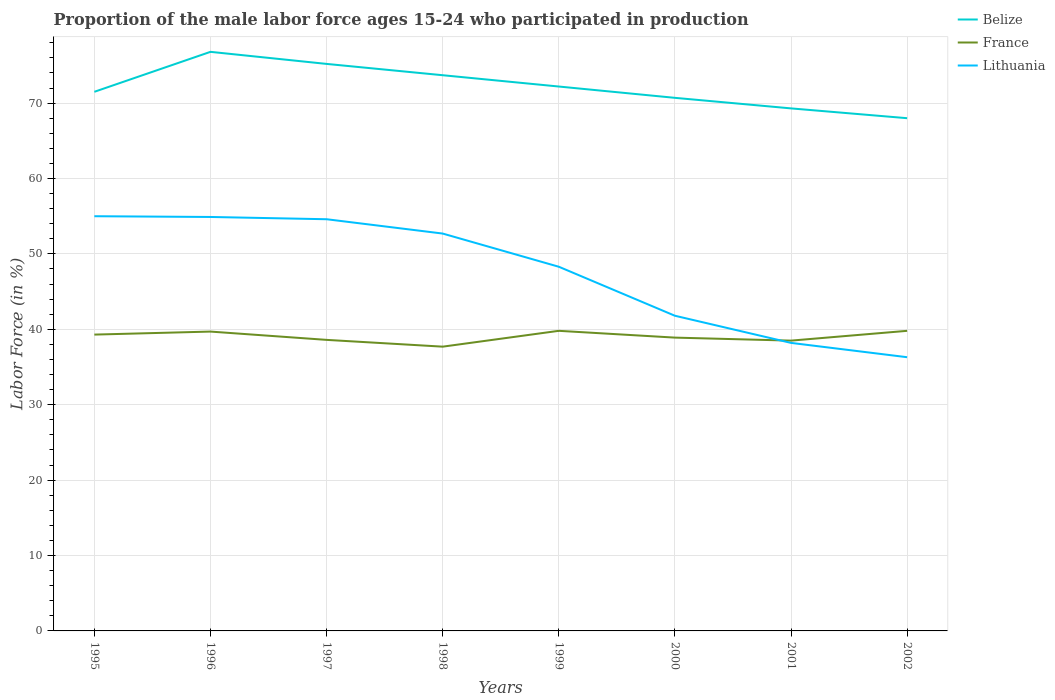Does the line corresponding to France intersect with the line corresponding to Belize?
Provide a short and direct response. No. In which year was the proportion of the male labor force who participated in production in Lithuania maximum?
Provide a succinct answer. 2002. What is the total proportion of the male labor force who participated in production in France in the graph?
Your response must be concise. -2.1. What is the difference between the highest and the second highest proportion of the male labor force who participated in production in Lithuania?
Your answer should be compact. 18.7. What is the difference between the highest and the lowest proportion of the male labor force who participated in production in Lithuania?
Your answer should be very brief. 5. Is the proportion of the male labor force who participated in production in France strictly greater than the proportion of the male labor force who participated in production in Belize over the years?
Provide a short and direct response. Yes. How many legend labels are there?
Give a very brief answer. 3. What is the title of the graph?
Provide a succinct answer. Proportion of the male labor force ages 15-24 who participated in production. Does "Mauritania" appear as one of the legend labels in the graph?
Offer a terse response. No. What is the label or title of the X-axis?
Offer a terse response. Years. What is the label or title of the Y-axis?
Offer a terse response. Labor Force (in %). What is the Labor Force (in %) of Belize in 1995?
Provide a succinct answer. 71.5. What is the Labor Force (in %) in France in 1995?
Offer a terse response. 39.3. What is the Labor Force (in %) in Belize in 1996?
Provide a succinct answer. 76.8. What is the Labor Force (in %) of France in 1996?
Your answer should be compact. 39.7. What is the Labor Force (in %) in Lithuania in 1996?
Provide a succinct answer. 54.9. What is the Labor Force (in %) of Belize in 1997?
Your response must be concise. 75.2. What is the Labor Force (in %) of France in 1997?
Provide a succinct answer. 38.6. What is the Labor Force (in %) of Lithuania in 1997?
Your answer should be compact. 54.6. What is the Labor Force (in %) in Belize in 1998?
Offer a very short reply. 73.7. What is the Labor Force (in %) in France in 1998?
Keep it short and to the point. 37.7. What is the Labor Force (in %) in Lithuania in 1998?
Offer a terse response. 52.7. What is the Labor Force (in %) in Belize in 1999?
Offer a terse response. 72.2. What is the Labor Force (in %) in France in 1999?
Offer a very short reply. 39.8. What is the Labor Force (in %) of Lithuania in 1999?
Provide a succinct answer. 48.3. What is the Labor Force (in %) of Belize in 2000?
Make the answer very short. 70.7. What is the Labor Force (in %) in France in 2000?
Your response must be concise. 38.9. What is the Labor Force (in %) of Lithuania in 2000?
Your response must be concise. 41.8. What is the Labor Force (in %) in Belize in 2001?
Your answer should be compact. 69.3. What is the Labor Force (in %) in France in 2001?
Keep it short and to the point. 38.5. What is the Labor Force (in %) in Lithuania in 2001?
Make the answer very short. 38.2. What is the Labor Force (in %) in France in 2002?
Offer a terse response. 39.8. What is the Labor Force (in %) in Lithuania in 2002?
Offer a very short reply. 36.3. Across all years, what is the maximum Labor Force (in %) in Belize?
Give a very brief answer. 76.8. Across all years, what is the maximum Labor Force (in %) of France?
Give a very brief answer. 39.8. Across all years, what is the maximum Labor Force (in %) of Lithuania?
Your answer should be compact. 55. Across all years, what is the minimum Labor Force (in %) of France?
Offer a very short reply. 37.7. Across all years, what is the minimum Labor Force (in %) in Lithuania?
Provide a short and direct response. 36.3. What is the total Labor Force (in %) in Belize in the graph?
Your response must be concise. 577.4. What is the total Labor Force (in %) in France in the graph?
Your response must be concise. 312.3. What is the total Labor Force (in %) in Lithuania in the graph?
Your answer should be very brief. 381.8. What is the difference between the Labor Force (in %) of Lithuania in 1995 and that in 1996?
Provide a succinct answer. 0.1. What is the difference between the Labor Force (in %) of France in 1995 and that in 1997?
Offer a terse response. 0.7. What is the difference between the Labor Force (in %) in Belize in 1995 and that in 1998?
Your response must be concise. -2.2. What is the difference between the Labor Force (in %) of France in 1995 and that in 1998?
Your answer should be compact. 1.6. What is the difference between the Labor Force (in %) in Lithuania in 1995 and that in 1998?
Your response must be concise. 2.3. What is the difference between the Labor Force (in %) of France in 1995 and that in 2000?
Your answer should be compact. 0.4. What is the difference between the Labor Force (in %) in France in 1995 and that in 2001?
Your answer should be very brief. 0.8. What is the difference between the Labor Force (in %) in Lithuania in 1995 and that in 2001?
Provide a succinct answer. 16.8. What is the difference between the Labor Force (in %) of France in 1995 and that in 2002?
Make the answer very short. -0.5. What is the difference between the Labor Force (in %) of Belize in 1996 and that in 1997?
Offer a very short reply. 1.6. What is the difference between the Labor Force (in %) of Lithuania in 1996 and that in 1997?
Your response must be concise. 0.3. What is the difference between the Labor Force (in %) in France in 1996 and that in 1998?
Your answer should be compact. 2. What is the difference between the Labor Force (in %) of Lithuania in 1996 and that in 1998?
Provide a short and direct response. 2.2. What is the difference between the Labor Force (in %) of Lithuania in 1996 and that in 1999?
Keep it short and to the point. 6.6. What is the difference between the Labor Force (in %) in Belize in 1996 and that in 2000?
Ensure brevity in your answer.  6.1. What is the difference between the Labor Force (in %) in France in 1996 and that in 2000?
Offer a very short reply. 0.8. What is the difference between the Labor Force (in %) of Belize in 1996 and that in 2001?
Ensure brevity in your answer.  7.5. What is the difference between the Labor Force (in %) in France in 1996 and that in 2001?
Ensure brevity in your answer.  1.2. What is the difference between the Labor Force (in %) in Lithuania in 1996 and that in 2001?
Keep it short and to the point. 16.7. What is the difference between the Labor Force (in %) in Belize in 1996 and that in 2002?
Give a very brief answer. 8.8. What is the difference between the Labor Force (in %) in Lithuania in 1996 and that in 2002?
Make the answer very short. 18.6. What is the difference between the Labor Force (in %) in France in 1997 and that in 1998?
Your answer should be compact. 0.9. What is the difference between the Labor Force (in %) of Lithuania in 1997 and that in 1998?
Offer a terse response. 1.9. What is the difference between the Labor Force (in %) in France in 1997 and that in 1999?
Provide a succinct answer. -1.2. What is the difference between the Labor Force (in %) in France in 1997 and that in 2000?
Keep it short and to the point. -0.3. What is the difference between the Labor Force (in %) in Lithuania in 1997 and that in 2000?
Give a very brief answer. 12.8. What is the difference between the Labor Force (in %) of France in 1997 and that in 2001?
Your response must be concise. 0.1. What is the difference between the Labor Force (in %) in Lithuania in 1997 and that in 2001?
Make the answer very short. 16.4. What is the difference between the Labor Force (in %) of France in 1997 and that in 2002?
Keep it short and to the point. -1.2. What is the difference between the Labor Force (in %) in Belize in 1998 and that in 1999?
Your response must be concise. 1.5. What is the difference between the Labor Force (in %) of Lithuania in 1998 and that in 1999?
Your answer should be compact. 4.4. What is the difference between the Labor Force (in %) of France in 1998 and that in 2000?
Provide a succinct answer. -1.2. What is the difference between the Labor Force (in %) of France in 1998 and that in 2001?
Offer a terse response. -0.8. What is the difference between the Labor Force (in %) in France in 1998 and that in 2002?
Provide a short and direct response. -2.1. What is the difference between the Labor Force (in %) in Lithuania in 1998 and that in 2002?
Offer a terse response. 16.4. What is the difference between the Labor Force (in %) of France in 1999 and that in 2000?
Provide a short and direct response. 0.9. What is the difference between the Labor Force (in %) in France in 1999 and that in 2001?
Make the answer very short. 1.3. What is the difference between the Labor Force (in %) of Belize in 1999 and that in 2002?
Offer a very short reply. 4.2. What is the difference between the Labor Force (in %) in France in 1999 and that in 2002?
Offer a terse response. 0. What is the difference between the Labor Force (in %) in Lithuania in 2001 and that in 2002?
Ensure brevity in your answer.  1.9. What is the difference between the Labor Force (in %) of Belize in 1995 and the Labor Force (in %) of France in 1996?
Your answer should be compact. 31.8. What is the difference between the Labor Force (in %) of Belize in 1995 and the Labor Force (in %) of Lithuania in 1996?
Give a very brief answer. 16.6. What is the difference between the Labor Force (in %) in France in 1995 and the Labor Force (in %) in Lithuania in 1996?
Offer a very short reply. -15.6. What is the difference between the Labor Force (in %) of Belize in 1995 and the Labor Force (in %) of France in 1997?
Ensure brevity in your answer.  32.9. What is the difference between the Labor Force (in %) in France in 1995 and the Labor Force (in %) in Lithuania in 1997?
Ensure brevity in your answer.  -15.3. What is the difference between the Labor Force (in %) of Belize in 1995 and the Labor Force (in %) of France in 1998?
Offer a terse response. 33.8. What is the difference between the Labor Force (in %) of Belize in 1995 and the Labor Force (in %) of Lithuania in 1998?
Provide a short and direct response. 18.8. What is the difference between the Labor Force (in %) of Belize in 1995 and the Labor Force (in %) of France in 1999?
Keep it short and to the point. 31.7. What is the difference between the Labor Force (in %) in Belize in 1995 and the Labor Force (in %) in Lithuania in 1999?
Keep it short and to the point. 23.2. What is the difference between the Labor Force (in %) of Belize in 1995 and the Labor Force (in %) of France in 2000?
Make the answer very short. 32.6. What is the difference between the Labor Force (in %) in Belize in 1995 and the Labor Force (in %) in Lithuania in 2000?
Your response must be concise. 29.7. What is the difference between the Labor Force (in %) of Belize in 1995 and the Labor Force (in %) of France in 2001?
Your answer should be very brief. 33. What is the difference between the Labor Force (in %) in Belize in 1995 and the Labor Force (in %) in Lithuania in 2001?
Keep it short and to the point. 33.3. What is the difference between the Labor Force (in %) in France in 1995 and the Labor Force (in %) in Lithuania in 2001?
Provide a short and direct response. 1.1. What is the difference between the Labor Force (in %) of Belize in 1995 and the Labor Force (in %) of France in 2002?
Your answer should be compact. 31.7. What is the difference between the Labor Force (in %) in Belize in 1995 and the Labor Force (in %) in Lithuania in 2002?
Offer a very short reply. 35.2. What is the difference between the Labor Force (in %) of Belize in 1996 and the Labor Force (in %) of France in 1997?
Your answer should be very brief. 38.2. What is the difference between the Labor Force (in %) of France in 1996 and the Labor Force (in %) of Lithuania in 1997?
Keep it short and to the point. -14.9. What is the difference between the Labor Force (in %) of Belize in 1996 and the Labor Force (in %) of France in 1998?
Provide a succinct answer. 39.1. What is the difference between the Labor Force (in %) of Belize in 1996 and the Labor Force (in %) of Lithuania in 1998?
Your answer should be very brief. 24.1. What is the difference between the Labor Force (in %) of Belize in 1996 and the Labor Force (in %) of Lithuania in 1999?
Offer a terse response. 28.5. What is the difference between the Labor Force (in %) in France in 1996 and the Labor Force (in %) in Lithuania in 1999?
Your response must be concise. -8.6. What is the difference between the Labor Force (in %) of Belize in 1996 and the Labor Force (in %) of France in 2000?
Provide a succinct answer. 37.9. What is the difference between the Labor Force (in %) in Belize in 1996 and the Labor Force (in %) in Lithuania in 2000?
Provide a short and direct response. 35. What is the difference between the Labor Force (in %) of France in 1996 and the Labor Force (in %) of Lithuania in 2000?
Your response must be concise. -2.1. What is the difference between the Labor Force (in %) of Belize in 1996 and the Labor Force (in %) of France in 2001?
Your answer should be compact. 38.3. What is the difference between the Labor Force (in %) of Belize in 1996 and the Labor Force (in %) of Lithuania in 2001?
Give a very brief answer. 38.6. What is the difference between the Labor Force (in %) in Belize in 1996 and the Labor Force (in %) in France in 2002?
Provide a succinct answer. 37. What is the difference between the Labor Force (in %) in Belize in 1996 and the Labor Force (in %) in Lithuania in 2002?
Offer a terse response. 40.5. What is the difference between the Labor Force (in %) of Belize in 1997 and the Labor Force (in %) of France in 1998?
Give a very brief answer. 37.5. What is the difference between the Labor Force (in %) in France in 1997 and the Labor Force (in %) in Lithuania in 1998?
Ensure brevity in your answer.  -14.1. What is the difference between the Labor Force (in %) of Belize in 1997 and the Labor Force (in %) of France in 1999?
Keep it short and to the point. 35.4. What is the difference between the Labor Force (in %) of Belize in 1997 and the Labor Force (in %) of Lithuania in 1999?
Your answer should be compact. 26.9. What is the difference between the Labor Force (in %) in France in 1997 and the Labor Force (in %) in Lithuania in 1999?
Offer a terse response. -9.7. What is the difference between the Labor Force (in %) in Belize in 1997 and the Labor Force (in %) in France in 2000?
Ensure brevity in your answer.  36.3. What is the difference between the Labor Force (in %) in Belize in 1997 and the Labor Force (in %) in Lithuania in 2000?
Make the answer very short. 33.4. What is the difference between the Labor Force (in %) of Belize in 1997 and the Labor Force (in %) of France in 2001?
Provide a short and direct response. 36.7. What is the difference between the Labor Force (in %) of Belize in 1997 and the Labor Force (in %) of Lithuania in 2001?
Keep it short and to the point. 37. What is the difference between the Labor Force (in %) in France in 1997 and the Labor Force (in %) in Lithuania in 2001?
Your answer should be very brief. 0.4. What is the difference between the Labor Force (in %) in Belize in 1997 and the Labor Force (in %) in France in 2002?
Make the answer very short. 35.4. What is the difference between the Labor Force (in %) of Belize in 1997 and the Labor Force (in %) of Lithuania in 2002?
Offer a very short reply. 38.9. What is the difference between the Labor Force (in %) in Belize in 1998 and the Labor Force (in %) in France in 1999?
Your response must be concise. 33.9. What is the difference between the Labor Force (in %) in Belize in 1998 and the Labor Force (in %) in Lithuania in 1999?
Your answer should be compact. 25.4. What is the difference between the Labor Force (in %) of France in 1998 and the Labor Force (in %) of Lithuania in 1999?
Give a very brief answer. -10.6. What is the difference between the Labor Force (in %) of Belize in 1998 and the Labor Force (in %) of France in 2000?
Provide a short and direct response. 34.8. What is the difference between the Labor Force (in %) in Belize in 1998 and the Labor Force (in %) in Lithuania in 2000?
Your answer should be very brief. 31.9. What is the difference between the Labor Force (in %) in Belize in 1998 and the Labor Force (in %) in France in 2001?
Ensure brevity in your answer.  35.2. What is the difference between the Labor Force (in %) of Belize in 1998 and the Labor Force (in %) of Lithuania in 2001?
Ensure brevity in your answer.  35.5. What is the difference between the Labor Force (in %) in France in 1998 and the Labor Force (in %) in Lithuania in 2001?
Offer a very short reply. -0.5. What is the difference between the Labor Force (in %) in Belize in 1998 and the Labor Force (in %) in France in 2002?
Offer a terse response. 33.9. What is the difference between the Labor Force (in %) of Belize in 1998 and the Labor Force (in %) of Lithuania in 2002?
Your answer should be very brief. 37.4. What is the difference between the Labor Force (in %) of Belize in 1999 and the Labor Force (in %) of France in 2000?
Your answer should be compact. 33.3. What is the difference between the Labor Force (in %) of Belize in 1999 and the Labor Force (in %) of Lithuania in 2000?
Give a very brief answer. 30.4. What is the difference between the Labor Force (in %) in Belize in 1999 and the Labor Force (in %) in France in 2001?
Make the answer very short. 33.7. What is the difference between the Labor Force (in %) in Belize in 1999 and the Labor Force (in %) in Lithuania in 2001?
Give a very brief answer. 34. What is the difference between the Labor Force (in %) in Belize in 1999 and the Labor Force (in %) in France in 2002?
Your response must be concise. 32.4. What is the difference between the Labor Force (in %) in Belize in 1999 and the Labor Force (in %) in Lithuania in 2002?
Your response must be concise. 35.9. What is the difference between the Labor Force (in %) in France in 1999 and the Labor Force (in %) in Lithuania in 2002?
Your response must be concise. 3.5. What is the difference between the Labor Force (in %) in Belize in 2000 and the Labor Force (in %) in France in 2001?
Your response must be concise. 32.2. What is the difference between the Labor Force (in %) of Belize in 2000 and the Labor Force (in %) of Lithuania in 2001?
Your response must be concise. 32.5. What is the difference between the Labor Force (in %) in France in 2000 and the Labor Force (in %) in Lithuania in 2001?
Offer a terse response. 0.7. What is the difference between the Labor Force (in %) in Belize in 2000 and the Labor Force (in %) in France in 2002?
Make the answer very short. 30.9. What is the difference between the Labor Force (in %) of Belize in 2000 and the Labor Force (in %) of Lithuania in 2002?
Your answer should be compact. 34.4. What is the difference between the Labor Force (in %) in France in 2000 and the Labor Force (in %) in Lithuania in 2002?
Provide a succinct answer. 2.6. What is the difference between the Labor Force (in %) in Belize in 2001 and the Labor Force (in %) in France in 2002?
Make the answer very short. 29.5. What is the difference between the Labor Force (in %) in France in 2001 and the Labor Force (in %) in Lithuania in 2002?
Your answer should be compact. 2.2. What is the average Labor Force (in %) in Belize per year?
Your answer should be compact. 72.17. What is the average Labor Force (in %) in France per year?
Provide a short and direct response. 39.04. What is the average Labor Force (in %) in Lithuania per year?
Make the answer very short. 47.73. In the year 1995, what is the difference between the Labor Force (in %) in Belize and Labor Force (in %) in France?
Your answer should be compact. 32.2. In the year 1995, what is the difference between the Labor Force (in %) of France and Labor Force (in %) of Lithuania?
Provide a succinct answer. -15.7. In the year 1996, what is the difference between the Labor Force (in %) of Belize and Labor Force (in %) of France?
Your answer should be very brief. 37.1. In the year 1996, what is the difference between the Labor Force (in %) of Belize and Labor Force (in %) of Lithuania?
Offer a terse response. 21.9. In the year 1996, what is the difference between the Labor Force (in %) in France and Labor Force (in %) in Lithuania?
Keep it short and to the point. -15.2. In the year 1997, what is the difference between the Labor Force (in %) of Belize and Labor Force (in %) of France?
Ensure brevity in your answer.  36.6. In the year 1997, what is the difference between the Labor Force (in %) of Belize and Labor Force (in %) of Lithuania?
Offer a terse response. 20.6. In the year 1998, what is the difference between the Labor Force (in %) of Belize and Labor Force (in %) of Lithuania?
Provide a short and direct response. 21. In the year 1999, what is the difference between the Labor Force (in %) of Belize and Labor Force (in %) of France?
Offer a very short reply. 32.4. In the year 1999, what is the difference between the Labor Force (in %) in Belize and Labor Force (in %) in Lithuania?
Offer a terse response. 23.9. In the year 1999, what is the difference between the Labor Force (in %) of France and Labor Force (in %) of Lithuania?
Keep it short and to the point. -8.5. In the year 2000, what is the difference between the Labor Force (in %) in Belize and Labor Force (in %) in France?
Your response must be concise. 31.8. In the year 2000, what is the difference between the Labor Force (in %) of Belize and Labor Force (in %) of Lithuania?
Give a very brief answer. 28.9. In the year 2000, what is the difference between the Labor Force (in %) in France and Labor Force (in %) in Lithuania?
Ensure brevity in your answer.  -2.9. In the year 2001, what is the difference between the Labor Force (in %) of Belize and Labor Force (in %) of France?
Provide a short and direct response. 30.8. In the year 2001, what is the difference between the Labor Force (in %) of Belize and Labor Force (in %) of Lithuania?
Offer a terse response. 31.1. In the year 2002, what is the difference between the Labor Force (in %) in Belize and Labor Force (in %) in France?
Offer a very short reply. 28.2. In the year 2002, what is the difference between the Labor Force (in %) of Belize and Labor Force (in %) of Lithuania?
Your answer should be compact. 31.7. In the year 2002, what is the difference between the Labor Force (in %) of France and Labor Force (in %) of Lithuania?
Offer a very short reply. 3.5. What is the ratio of the Labor Force (in %) of France in 1995 to that in 1996?
Make the answer very short. 0.99. What is the ratio of the Labor Force (in %) of Lithuania in 1995 to that in 1996?
Your response must be concise. 1. What is the ratio of the Labor Force (in %) of Belize in 1995 to that in 1997?
Offer a very short reply. 0.95. What is the ratio of the Labor Force (in %) of France in 1995 to that in 1997?
Offer a terse response. 1.02. What is the ratio of the Labor Force (in %) in Lithuania in 1995 to that in 1997?
Keep it short and to the point. 1.01. What is the ratio of the Labor Force (in %) of Belize in 1995 to that in 1998?
Your answer should be very brief. 0.97. What is the ratio of the Labor Force (in %) of France in 1995 to that in 1998?
Your response must be concise. 1.04. What is the ratio of the Labor Force (in %) of Lithuania in 1995 to that in 1998?
Your response must be concise. 1.04. What is the ratio of the Labor Force (in %) in Belize in 1995 to that in 1999?
Provide a short and direct response. 0.99. What is the ratio of the Labor Force (in %) in France in 1995 to that in 1999?
Provide a succinct answer. 0.99. What is the ratio of the Labor Force (in %) of Lithuania in 1995 to that in 1999?
Ensure brevity in your answer.  1.14. What is the ratio of the Labor Force (in %) in Belize in 1995 to that in 2000?
Provide a short and direct response. 1.01. What is the ratio of the Labor Force (in %) of France in 1995 to that in 2000?
Ensure brevity in your answer.  1.01. What is the ratio of the Labor Force (in %) of Lithuania in 1995 to that in 2000?
Your answer should be very brief. 1.32. What is the ratio of the Labor Force (in %) of Belize in 1995 to that in 2001?
Offer a very short reply. 1.03. What is the ratio of the Labor Force (in %) in France in 1995 to that in 2001?
Give a very brief answer. 1.02. What is the ratio of the Labor Force (in %) of Lithuania in 1995 to that in 2001?
Your answer should be compact. 1.44. What is the ratio of the Labor Force (in %) of Belize in 1995 to that in 2002?
Give a very brief answer. 1.05. What is the ratio of the Labor Force (in %) in France in 1995 to that in 2002?
Ensure brevity in your answer.  0.99. What is the ratio of the Labor Force (in %) of Lithuania in 1995 to that in 2002?
Ensure brevity in your answer.  1.52. What is the ratio of the Labor Force (in %) of Belize in 1996 to that in 1997?
Your answer should be very brief. 1.02. What is the ratio of the Labor Force (in %) of France in 1996 to that in 1997?
Make the answer very short. 1.03. What is the ratio of the Labor Force (in %) of Lithuania in 1996 to that in 1997?
Keep it short and to the point. 1.01. What is the ratio of the Labor Force (in %) in Belize in 1996 to that in 1998?
Provide a short and direct response. 1.04. What is the ratio of the Labor Force (in %) in France in 1996 to that in 1998?
Provide a short and direct response. 1.05. What is the ratio of the Labor Force (in %) in Lithuania in 1996 to that in 1998?
Keep it short and to the point. 1.04. What is the ratio of the Labor Force (in %) in Belize in 1996 to that in 1999?
Ensure brevity in your answer.  1.06. What is the ratio of the Labor Force (in %) of Lithuania in 1996 to that in 1999?
Ensure brevity in your answer.  1.14. What is the ratio of the Labor Force (in %) in Belize in 1996 to that in 2000?
Provide a short and direct response. 1.09. What is the ratio of the Labor Force (in %) of France in 1996 to that in 2000?
Keep it short and to the point. 1.02. What is the ratio of the Labor Force (in %) in Lithuania in 1996 to that in 2000?
Your answer should be very brief. 1.31. What is the ratio of the Labor Force (in %) of Belize in 1996 to that in 2001?
Make the answer very short. 1.11. What is the ratio of the Labor Force (in %) of France in 1996 to that in 2001?
Your response must be concise. 1.03. What is the ratio of the Labor Force (in %) in Lithuania in 1996 to that in 2001?
Offer a terse response. 1.44. What is the ratio of the Labor Force (in %) in Belize in 1996 to that in 2002?
Give a very brief answer. 1.13. What is the ratio of the Labor Force (in %) in France in 1996 to that in 2002?
Your answer should be very brief. 1. What is the ratio of the Labor Force (in %) in Lithuania in 1996 to that in 2002?
Give a very brief answer. 1.51. What is the ratio of the Labor Force (in %) in Belize in 1997 to that in 1998?
Your response must be concise. 1.02. What is the ratio of the Labor Force (in %) of France in 1997 to that in 1998?
Offer a terse response. 1.02. What is the ratio of the Labor Force (in %) of Lithuania in 1997 to that in 1998?
Provide a succinct answer. 1.04. What is the ratio of the Labor Force (in %) in Belize in 1997 to that in 1999?
Your response must be concise. 1.04. What is the ratio of the Labor Force (in %) in France in 1997 to that in 1999?
Your response must be concise. 0.97. What is the ratio of the Labor Force (in %) in Lithuania in 1997 to that in 1999?
Your answer should be very brief. 1.13. What is the ratio of the Labor Force (in %) in Belize in 1997 to that in 2000?
Your answer should be compact. 1.06. What is the ratio of the Labor Force (in %) in France in 1997 to that in 2000?
Your answer should be very brief. 0.99. What is the ratio of the Labor Force (in %) in Lithuania in 1997 to that in 2000?
Offer a terse response. 1.31. What is the ratio of the Labor Force (in %) of Belize in 1997 to that in 2001?
Keep it short and to the point. 1.09. What is the ratio of the Labor Force (in %) in Lithuania in 1997 to that in 2001?
Provide a succinct answer. 1.43. What is the ratio of the Labor Force (in %) in Belize in 1997 to that in 2002?
Ensure brevity in your answer.  1.11. What is the ratio of the Labor Force (in %) in France in 1997 to that in 2002?
Your response must be concise. 0.97. What is the ratio of the Labor Force (in %) of Lithuania in 1997 to that in 2002?
Offer a terse response. 1.5. What is the ratio of the Labor Force (in %) in Belize in 1998 to that in 1999?
Keep it short and to the point. 1.02. What is the ratio of the Labor Force (in %) of France in 1998 to that in 1999?
Provide a short and direct response. 0.95. What is the ratio of the Labor Force (in %) in Lithuania in 1998 to that in 1999?
Provide a short and direct response. 1.09. What is the ratio of the Labor Force (in %) in Belize in 1998 to that in 2000?
Your response must be concise. 1.04. What is the ratio of the Labor Force (in %) of France in 1998 to that in 2000?
Provide a short and direct response. 0.97. What is the ratio of the Labor Force (in %) in Lithuania in 1998 to that in 2000?
Offer a terse response. 1.26. What is the ratio of the Labor Force (in %) in Belize in 1998 to that in 2001?
Provide a short and direct response. 1.06. What is the ratio of the Labor Force (in %) in France in 1998 to that in 2001?
Ensure brevity in your answer.  0.98. What is the ratio of the Labor Force (in %) in Lithuania in 1998 to that in 2001?
Your response must be concise. 1.38. What is the ratio of the Labor Force (in %) of Belize in 1998 to that in 2002?
Provide a succinct answer. 1.08. What is the ratio of the Labor Force (in %) in France in 1998 to that in 2002?
Your answer should be compact. 0.95. What is the ratio of the Labor Force (in %) of Lithuania in 1998 to that in 2002?
Your answer should be compact. 1.45. What is the ratio of the Labor Force (in %) in Belize in 1999 to that in 2000?
Offer a terse response. 1.02. What is the ratio of the Labor Force (in %) in France in 1999 to that in 2000?
Provide a short and direct response. 1.02. What is the ratio of the Labor Force (in %) of Lithuania in 1999 to that in 2000?
Your response must be concise. 1.16. What is the ratio of the Labor Force (in %) in Belize in 1999 to that in 2001?
Your answer should be very brief. 1.04. What is the ratio of the Labor Force (in %) of France in 1999 to that in 2001?
Your answer should be very brief. 1.03. What is the ratio of the Labor Force (in %) in Lithuania in 1999 to that in 2001?
Offer a terse response. 1.26. What is the ratio of the Labor Force (in %) of Belize in 1999 to that in 2002?
Provide a succinct answer. 1.06. What is the ratio of the Labor Force (in %) of Lithuania in 1999 to that in 2002?
Your answer should be compact. 1.33. What is the ratio of the Labor Force (in %) in Belize in 2000 to that in 2001?
Your response must be concise. 1.02. What is the ratio of the Labor Force (in %) of France in 2000 to that in 2001?
Provide a succinct answer. 1.01. What is the ratio of the Labor Force (in %) of Lithuania in 2000 to that in 2001?
Give a very brief answer. 1.09. What is the ratio of the Labor Force (in %) in Belize in 2000 to that in 2002?
Give a very brief answer. 1.04. What is the ratio of the Labor Force (in %) in France in 2000 to that in 2002?
Provide a short and direct response. 0.98. What is the ratio of the Labor Force (in %) in Lithuania in 2000 to that in 2002?
Offer a very short reply. 1.15. What is the ratio of the Labor Force (in %) in Belize in 2001 to that in 2002?
Offer a very short reply. 1.02. What is the ratio of the Labor Force (in %) in France in 2001 to that in 2002?
Offer a terse response. 0.97. What is the ratio of the Labor Force (in %) of Lithuania in 2001 to that in 2002?
Offer a terse response. 1.05. What is the difference between the highest and the lowest Labor Force (in %) of Belize?
Provide a succinct answer. 8.8. What is the difference between the highest and the lowest Labor Force (in %) in France?
Provide a succinct answer. 2.1. What is the difference between the highest and the lowest Labor Force (in %) in Lithuania?
Your response must be concise. 18.7. 